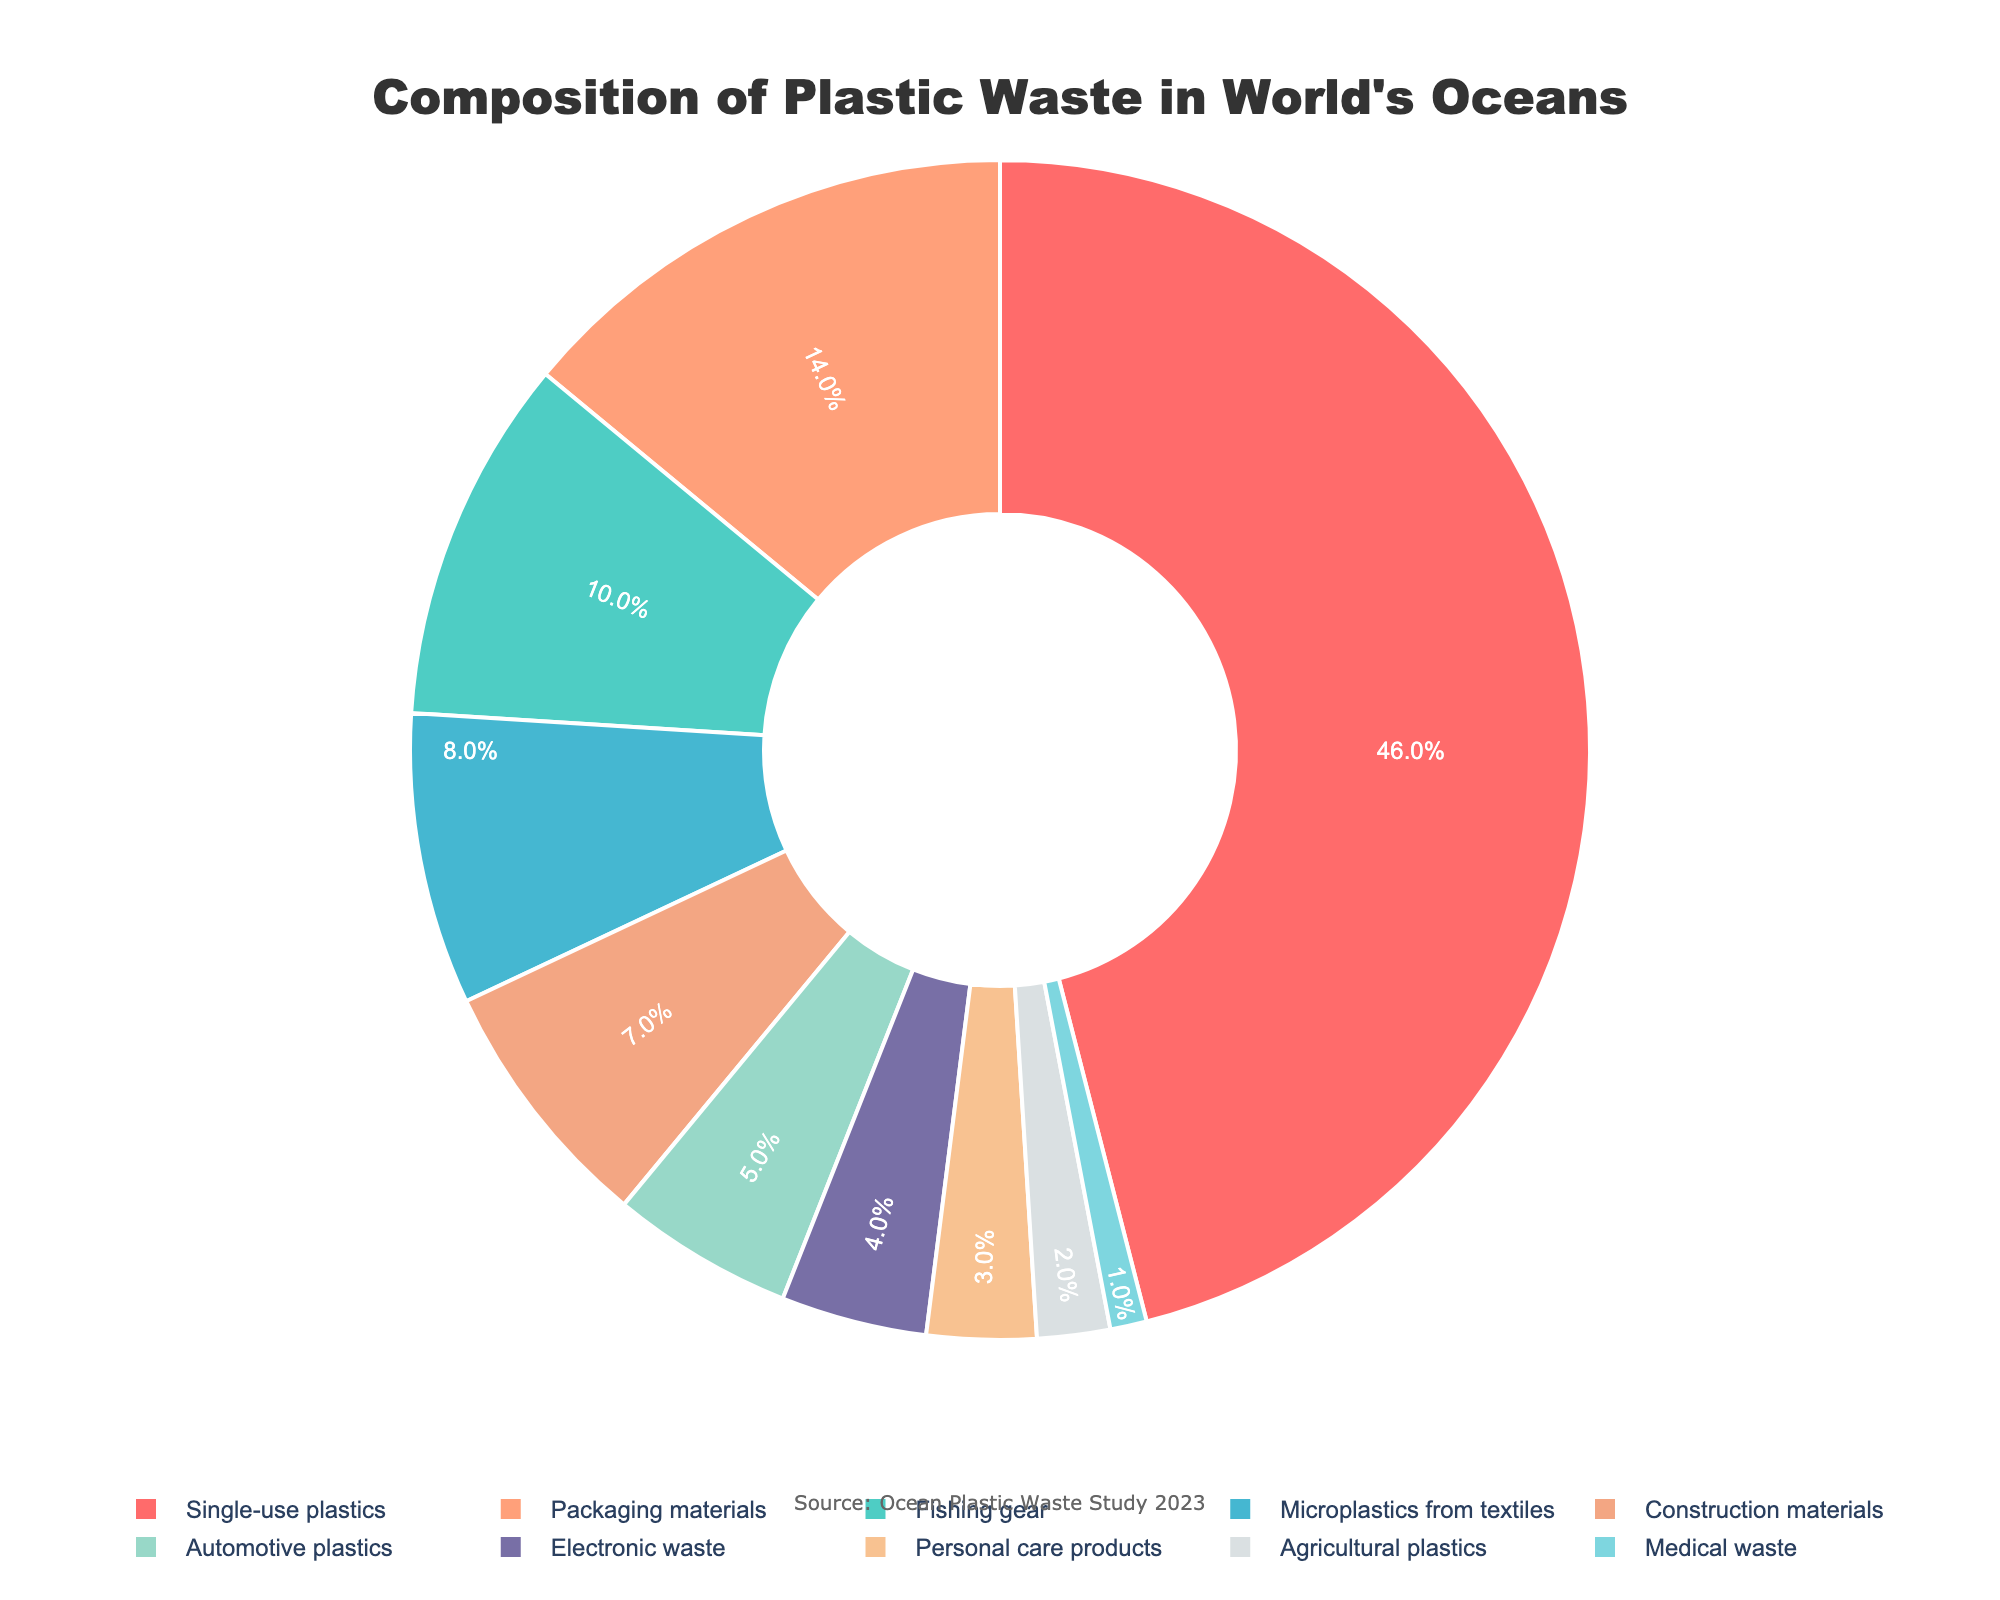What's the largest source of plastic waste in the world's oceans? The pie chart indicates that "Single-use plastics" constitute the largest portion of the plastic waste in the ocean, occupying the largest segment of the chart.
Answer: Single-use plastics Which sources contribute % by weight to plastic waste more than 10%? By examining the pie chart, "Single-use plastics" (46%) and "Packaging materials" (14%) are the two segments that exceed 10% of total plastic waste by weight.
Answer: Single-use plastics and Packaging materials What's the difference between the contributions of "Fishing gear" and "Packaging materials" to ocean plastic waste? "Packaging materials" contribute 14% while "Fishing gear" contributes 10%. The difference between them is 14% - 10% = 4%.
Answer: 4% What percentage of plastic waste is composed of sources contributing less than 5% each? Summing up the percentages of sources contributing less than 5%: "Electronic waste" (4%) + "Personal care products" (3%) + "Agricultural plastics" (2%) + "Medical waste" (1%) = 4% + 3% + 2% + 1% = 10%.
Answer: 10% Are microplastics from textiles contributing more or less plastic waste compared to automotive plastics? Referring to the pie chart, "Microplastics from textiles" account for 8% and "Automotive plastics" account for 5%, indicating that microplastics from textiles contribute more.
Answer: More Do agricultural plastics and medical waste combined contribute more than personal care products? Combined contribution of "Agricultural plastics" (2%) and "Medical waste" (1%) is 2% + 1% = 3%, which is equal to the contribution of "Personal care products" (3%). Hence, they contribute the same amount.
Answer: Equal What visual attribute represents the smallest category of plastic waste and what percentage does it hold? According to the pie chart, the smallest slice, which is colored darker blue, represents "Medical waste" at 1%.
Answer: Medical waste, 1% What is the total percentage of ocean plastic waste from single-use plastics, packaging materials, and construction materials? Adding the percentages together: "Single-use plastics" (46%) + "Packaging materials" (14%) + "Construction materials" (7%) = 46% + 14% + 7% = 67%.
Answer: 67% What is the second smallest contributor to ocean plastic waste? The pie chart shows the smallest contributor as "Medical waste" at 1%. The next smallest segment represents "Agricultural plastics" at 2%.
Answer: Agricultural plastics 